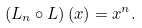<formula> <loc_0><loc_0><loc_500><loc_500>\left ( L _ { n } \circ L \right ) ( x ) = x ^ { n } .</formula> 